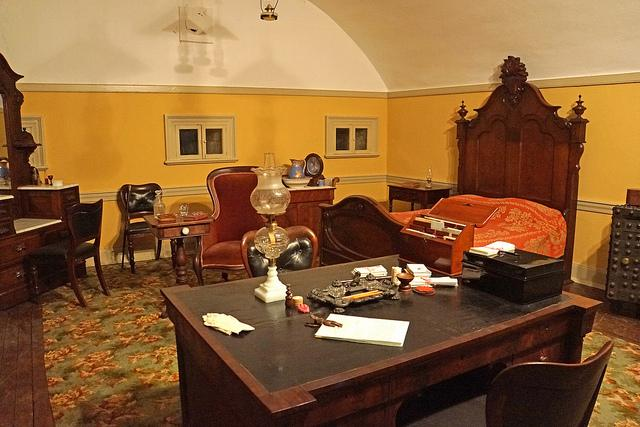What kind of fuel does the lamp use? oil 